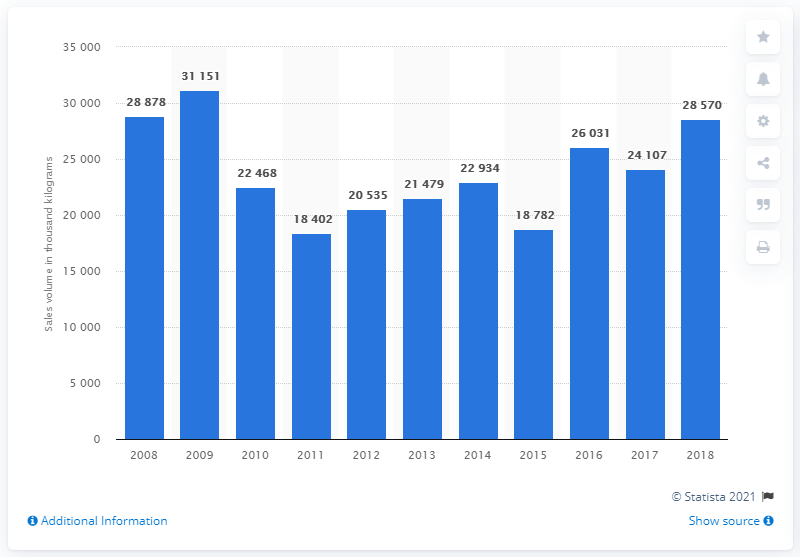Can you describe the trend in sales volume from 2008 to 2018? From 2008 to 2018, the sales volume of mixed fruit and nuts initially saw an increase, peaking in 2009 at 31,151 thousand kilograms. It fluctuated over the years, generally showing a downward trend towards 2018. 